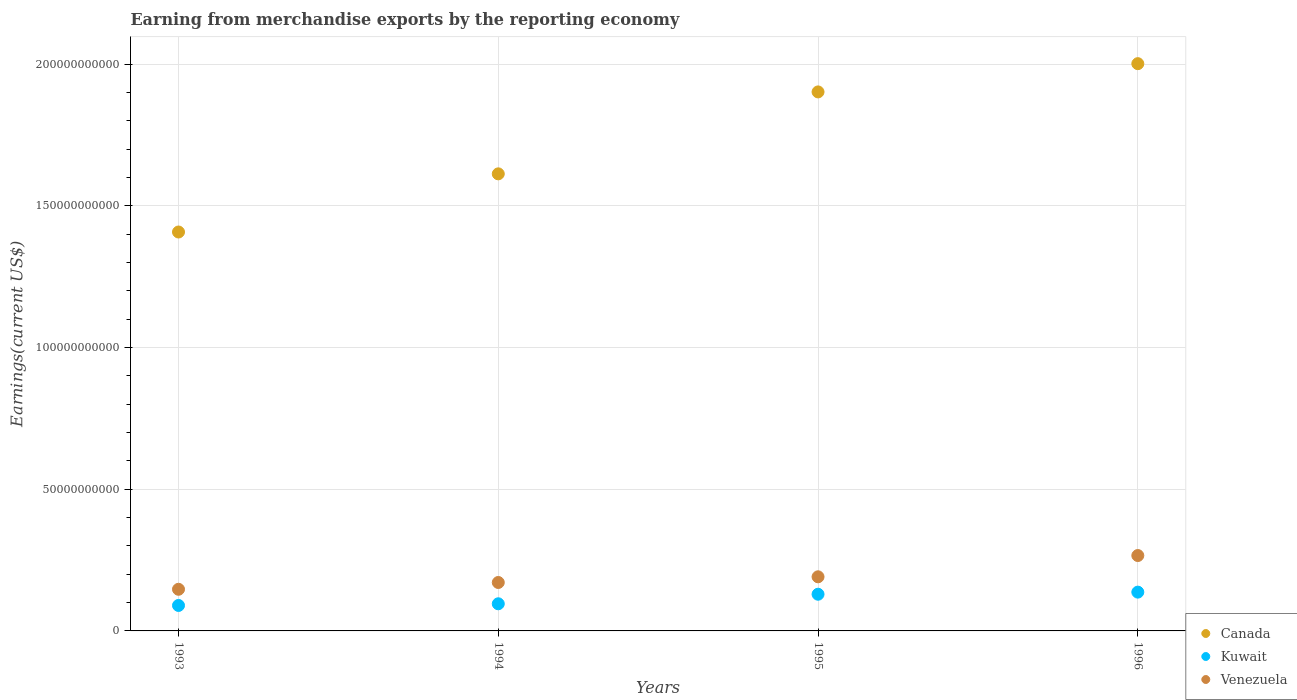What is the amount earned from merchandise exports in Kuwait in 1995?
Offer a terse response. 1.29e+1. Across all years, what is the maximum amount earned from merchandise exports in Kuwait?
Ensure brevity in your answer.  1.37e+1. Across all years, what is the minimum amount earned from merchandise exports in Canada?
Your answer should be very brief. 1.41e+11. In which year was the amount earned from merchandise exports in Venezuela maximum?
Ensure brevity in your answer.  1996. What is the total amount earned from merchandise exports in Canada in the graph?
Ensure brevity in your answer.  6.92e+11. What is the difference between the amount earned from merchandise exports in Venezuela in 1994 and that in 1996?
Provide a short and direct response. -9.51e+09. What is the difference between the amount earned from merchandise exports in Canada in 1995 and the amount earned from merchandise exports in Kuwait in 1996?
Your answer should be compact. 1.76e+11. What is the average amount earned from merchandise exports in Venezuela per year?
Provide a succinct answer. 1.94e+1. In the year 1994, what is the difference between the amount earned from merchandise exports in Kuwait and amount earned from merchandise exports in Canada?
Provide a succinct answer. -1.52e+11. What is the ratio of the amount earned from merchandise exports in Canada in 1993 to that in 1995?
Provide a succinct answer. 0.74. Is the amount earned from merchandise exports in Kuwait in 1993 less than that in 1994?
Your answer should be very brief. Yes. Is the difference between the amount earned from merchandise exports in Kuwait in 1993 and 1996 greater than the difference between the amount earned from merchandise exports in Canada in 1993 and 1996?
Give a very brief answer. Yes. What is the difference between the highest and the second highest amount earned from merchandise exports in Canada?
Your answer should be compact. 9.97e+09. What is the difference between the highest and the lowest amount earned from merchandise exports in Venezuela?
Provide a succinct answer. 1.19e+1. In how many years, is the amount earned from merchandise exports in Canada greater than the average amount earned from merchandise exports in Canada taken over all years?
Provide a short and direct response. 2. Is it the case that in every year, the sum of the amount earned from merchandise exports in Venezuela and amount earned from merchandise exports in Kuwait  is greater than the amount earned from merchandise exports in Canada?
Provide a succinct answer. No. Does the amount earned from merchandise exports in Kuwait monotonically increase over the years?
Make the answer very short. Yes. Is the amount earned from merchandise exports in Canada strictly greater than the amount earned from merchandise exports in Kuwait over the years?
Provide a succinct answer. Yes. Is the amount earned from merchandise exports in Kuwait strictly less than the amount earned from merchandise exports in Canada over the years?
Provide a succinct answer. Yes. How many years are there in the graph?
Provide a succinct answer. 4. What is the title of the graph?
Provide a short and direct response. Earning from merchandise exports by the reporting economy. Does "High income: OECD" appear as one of the legend labels in the graph?
Offer a terse response. No. What is the label or title of the Y-axis?
Provide a short and direct response. Earnings(current US$). What is the Earnings(current US$) of Canada in 1993?
Offer a very short reply. 1.41e+11. What is the Earnings(current US$) of Kuwait in 1993?
Give a very brief answer. 8.98e+09. What is the Earnings(current US$) of Venezuela in 1993?
Make the answer very short. 1.47e+1. What is the Earnings(current US$) of Canada in 1994?
Keep it short and to the point. 1.61e+11. What is the Earnings(current US$) in Kuwait in 1994?
Your answer should be compact. 9.58e+09. What is the Earnings(current US$) of Venezuela in 1994?
Provide a succinct answer. 1.71e+1. What is the Earnings(current US$) in Canada in 1995?
Offer a very short reply. 1.90e+11. What is the Earnings(current US$) in Kuwait in 1995?
Keep it short and to the point. 1.29e+1. What is the Earnings(current US$) of Venezuela in 1995?
Give a very brief answer. 1.91e+1. What is the Earnings(current US$) of Canada in 1996?
Ensure brevity in your answer.  2.00e+11. What is the Earnings(current US$) of Kuwait in 1996?
Offer a terse response. 1.37e+1. What is the Earnings(current US$) in Venezuela in 1996?
Your response must be concise. 2.66e+1. Across all years, what is the maximum Earnings(current US$) in Canada?
Make the answer very short. 2.00e+11. Across all years, what is the maximum Earnings(current US$) of Kuwait?
Offer a very short reply. 1.37e+1. Across all years, what is the maximum Earnings(current US$) in Venezuela?
Ensure brevity in your answer.  2.66e+1. Across all years, what is the minimum Earnings(current US$) in Canada?
Provide a succinct answer. 1.41e+11. Across all years, what is the minimum Earnings(current US$) in Kuwait?
Offer a very short reply. 8.98e+09. Across all years, what is the minimum Earnings(current US$) in Venezuela?
Give a very brief answer. 1.47e+1. What is the total Earnings(current US$) of Canada in the graph?
Provide a short and direct response. 6.92e+11. What is the total Earnings(current US$) in Kuwait in the graph?
Your answer should be very brief. 4.52e+1. What is the total Earnings(current US$) in Venezuela in the graph?
Provide a short and direct response. 7.75e+1. What is the difference between the Earnings(current US$) in Canada in 1993 and that in 1994?
Keep it short and to the point. -2.05e+1. What is the difference between the Earnings(current US$) in Kuwait in 1993 and that in 1994?
Your answer should be compact. -5.93e+08. What is the difference between the Earnings(current US$) in Venezuela in 1993 and that in 1994?
Offer a very short reply. -2.40e+09. What is the difference between the Earnings(current US$) in Canada in 1993 and that in 1995?
Keep it short and to the point. -4.94e+1. What is the difference between the Earnings(current US$) in Kuwait in 1993 and that in 1995?
Provide a succinct answer. -3.96e+09. What is the difference between the Earnings(current US$) of Venezuela in 1993 and that in 1995?
Your answer should be very brief. -4.40e+09. What is the difference between the Earnings(current US$) of Canada in 1993 and that in 1996?
Keep it short and to the point. -5.94e+1. What is the difference between the Earnings(current US$) in Kuwait in 1993 and that in 1996?
Offer a very short reply. -4.70e+09. What is the difference between the Earnings(current US$) of Venezuela in 1993 and that in 1996?
Provide a succinct answer. -1.19e+1. What is the difference between the Earnings(current US$) in Canada in 1994 and that in 1995?
Give a very brief answer. -2.89e+1. What is the difference between the Earnings(current US$) of Kuwait in 1994 and that in 1995?
Provide a short and direct response. -3.37e+09. What is the difference between the Earnings(current US$) of Venezuela in 1994 and that in 1995?
Ensure brevity in your answer.  -2.00e+09. What is the difference between the Earnings(current US$) of Canada in 1994 and that in 1996?
Your answer should be compact. -3.89e+1. What is the difference between the Earnings(current US$) in Kuwait in 1994 and that in 1996?
Your answer should be very brief. -4.11e+09. What is the difference between the Earnings(current US$) of Venezuela in 1994 and that in 1996?
Make the answer very short. -9.51e+09. What is the difference between the Earnings(current US$) of Canada in 1995 and that in 1996?
Your response must be concise. -9.97e+09. What is the difference between the Earnings(current US$) of Kuwait in 1995 and that in 1996?
Offer a terse response. -7.43e+08. What is the difference between the Earnings(current US$) in Venezuela in 1995 and that in 1996?
Ensure brevity in your answer.  -7.51e+09. What is the difference between the Earnings(current US$) of Canada in 1993 and the Earnings(current US$) of Kuwait in 1994?
Your answer should be very brief. 1.31e+11. What is the difference between the Earnings(current US$) of Canada in 1993 and the Earnings(current US$) of Venezuela in 1994?
Provide a succinct answer. 1.24e+11. What is the difference between the Earnings(current US$) of Kuwait in 1993 and the Earnings(current US$) of Venezuela in 1994?
Make the answer very short. -8.11e+09. What is the difference between the Earnings(current US$) in Canada in 1993 and the Earnings(current US$) in Kuwait in 1995?
Provide a short and direct response. 1.28e+11. What is the difference between the Earnings(current US$) in Canada in 1993 and the Earnings(current US$) in Venezuela in 1995?
Your answer should be compact. 1.22e+11. What is the difference between the Earnings(current US$) of Kuwait in 1993 and the Earnings(current US$) of Venezuela in 1995?
Your answer should be very brief. -1.01e+1. What is the difference between the Earnings(current US$) of Canada in 1993 and the Earnings(current US$) of Kuwait in 1996?
Your response must be concise. 1.27e+11. What is the difference between the Earnings(current US$) of Canada in 1993 and the Earnings(current US$) of Venezuela in 1996?
Your answer should be compact. 1.14e+11. What is the difference between the Earnings(current US$) in Kuwait in 1993 and the Earnings(current US$) in Venezuela in 1996?
Provide a short and direct response. -1.76e+1. What is the difference between the Earnings(current US$) of Canada in 1994 and the Earnings(current US$) of Kuwait in 1995?
Provide a succinct answer. 1.48e+11. What is the difference between the Earnings(current US$) of Canada in 1994 and the Earnings(current US$) of Venezuela in 1995?
Provide a succinct answer. 1.42e+11. What is the difference between the Earnings(current US$) of Kuwait in 1994 and the Earnings(current US$) of Venezuela in 1995?
Give a very brief answer. -9.52e+09. What is the difference between the Earnings(current US$) in Canada in 1994 and the Earnings(current US$) in Kuwait in 1996?
Your answer should be very brief. 1.48e+11. What is the difference between the Earnings(current US$) in Canada in 1994 and the Earnings(current US$) in Venezuela in 1996?
Ensure brevity in your answer.  1.35e+11. What is the difference between the Earnings(current US$) in Kuwait in 1994 and the Earnings(current US$) in Venezuela in 1996?
Give a very brief answer. -1.70e+1. What is the difference between the Earnings(current US$) in Canada in 1995 and the Earnings(current US$) in Kuwait in 1996?
Your response must be concise. 1.76e+11. What is the difference between the Earnings(current US$) in Canada in 1995 and the Earnings(current US$) in Venezuela in 1996?
Ensure brevity in your answer.  1.64e+11. What is the difference between the Earnings(current US$) of Kuwait in 1995 and the Earnings(current US$) of Venezuela in 1996?
Your answer should be compact. -1.37e+1. What is the average Earnings(current US$) in Canada per year?
Provide a succinct answer. 1.73e+11. What is the average Earnings(current US$) of Kuwait per year?
Provide a short and direct response. 1.13e+1. What is the average Earnings(current US$) in Venezuela per year?
Make the answer very short. 1.94e+1. In the year 1993, what is the difference between the Earnings(current US$) in Canada and Earnings(current US$) in Kuwait?
Your answer should be very brief. 1.32e+11. In the year 1993, what is the difference between the Earnings(current US$) in Canada and Earnings(current US$) in Venezuela?
Offer a very short reply. 1.26e+11. In the year 1993, what is the difference between the Earnings(current US$) of Kuwait and Earnings(current US$) of Venezuela?
Make the answer very short. -5.71e+09. In the year 1994, what is the difference between the Earnings(current US$) in Canada and Earnings(current US$) in Kuwait?
Ensure brevity in your answer.  1.52e+11. In the year 1994, what is the difference between the Earnings(current US$) in Canada and Earnings(current US$) in Venezuela?
Give a very brief answer. 1.44e+11. In the year 1994, what is the difference between the Earnings(current US$) of Kuwait and Earnings(current US$) of Venezuela?
Provide a succinct answer. -7.51e+09. In the year 1995, what is the difference between the Earnings(current US$) of Canada and Earnings(current US$) of Kuwait?
Keep it short and to the point. 1.77e+11. In the year 1995, what is the difference between the Earnings(current US$) in Canada and Earnings(current US$) in Venezuela?
Provide a short and direct response. 1.71e+11. In the year 1995, what is the difference between the Earnings(current US$) of Kuwait and Earnings(current US$) of Venezuela?
Offer a very short reply. -6.15e+09. In the year 1996, what is the difference between the Earnings(current US$) of Canada and Earnings(current US$) of Kuwait?
Offer a terse response. 1.86e+11. In the year 1996, what is the difference between the Earnings(current US$) of Canada and Earnings(current US$) of Venezuela?
Make the answer very short. 1.74e+11. In the year 1996, what is the difference between the Earnings(current US$) of Kuwait and Earnings(current US$) of Venezuela?
Offer a terse response. -1.29e+1. What is the ratio of the Earnings(current US$) of Canada in 1993 to that in 1994?
Offer a terse response. 0.87. What is the ratio of the Earnings(current US$) of Kuwait in 1993 to that in 1994?
Make the answer very short. 0.94. What is the ratio of the Earnings(current US$) of Venezuela in 1993 to that in 1994?
Provide a succinct answer. 0.86. What is the ratio of the Earnings(current US$) in Canada in 1993 to that in 1995?
Provide a succinct answer. 0.74. What is the ratio of the Earnings(current US$) of Kuwait in 1993 to that in 1995?
Provide a succinct answer. 0.69. What is the ratio of the Earnings(current US$) in Venezuela in 1993 to that in 1995?
Provide a succinct answer. 0.77. What is the ratio of the Earnings(current US$) of Canada in 1993 to that in 1996?
Make the answer very short. 0.7. What is the ratio of the Earnings(current US$) of Kuwait in 1993 to that in 1996?
Your response must be concise. 0.66. What is the ratio of the Earnings(current US$) in Venezuela in 1993 to that in 1996?
Keep it short and to the point. 0.55. What is the ratio of the Earnings(current US$) in Canada in 1994 to that in 1995?
Provide a succinct answer. 0.85. What is the ratio of the Earnings(current US$) of Kuwait in 1994 to that in 1995?
Your answer should be very brief. 0.74. What is the ratio of the Earnings(current US$) of Venezuela in 1994 to that in 1995?
Offer a very short reply. 0.9. What is the ratio of the Earnings(current US$) of Canada in 1994 to that in 1996?
Your answer should be compact. 0.81. What is the ratio of the Earnings(current US$) of Kuwait in 1994 to that in 1996?
Provide a short and direct response. 0.7. What is the ratio of the Earnings(current US$) in Venezuela in 1994 to that in 1996?
Keep it short and to the point. 0.64. What is the ratio of the Earnings(current US$) in Canada in 1995 to that in 1996?
Your answer should be compact. 0.95. What is the ratio of the Earnings(current US$) in Kuwait in 1995 to that in 1996?
Your response must be concise. 0.95. What is the ratio of the Earnings(current US$) of Venezuela in 1995 to that in 1996?
Offer a very short reply. 0.72. What is the difference between the highest and the second highest Earnings(current US$) of Canada?
Ensure brevity in your answer.  9.97e+09. What is the difference between the highest and the second highest Earnings(current US$) of Kuwait?
Ensure brevity in your answer.  7.43e+08. What is the difference between the highest and the second highest Earnings(current US$) in Venezuela?
Provide a succinct answer. 7.51e+09. What is the difference between the highest and the lowest Earnings(current US$) of Canada?
Ensure brevity in your answer.  5.94e+1. What is the difference between the highest and the lowest Earnings(current US$) in Kuwait?
Provide a succinct answer. 4.70e+09. What is the difference between the highest and the lowest Earnings(current US$) in Venezuela?
Ensure brevity in your answer.  1.19e+1. 